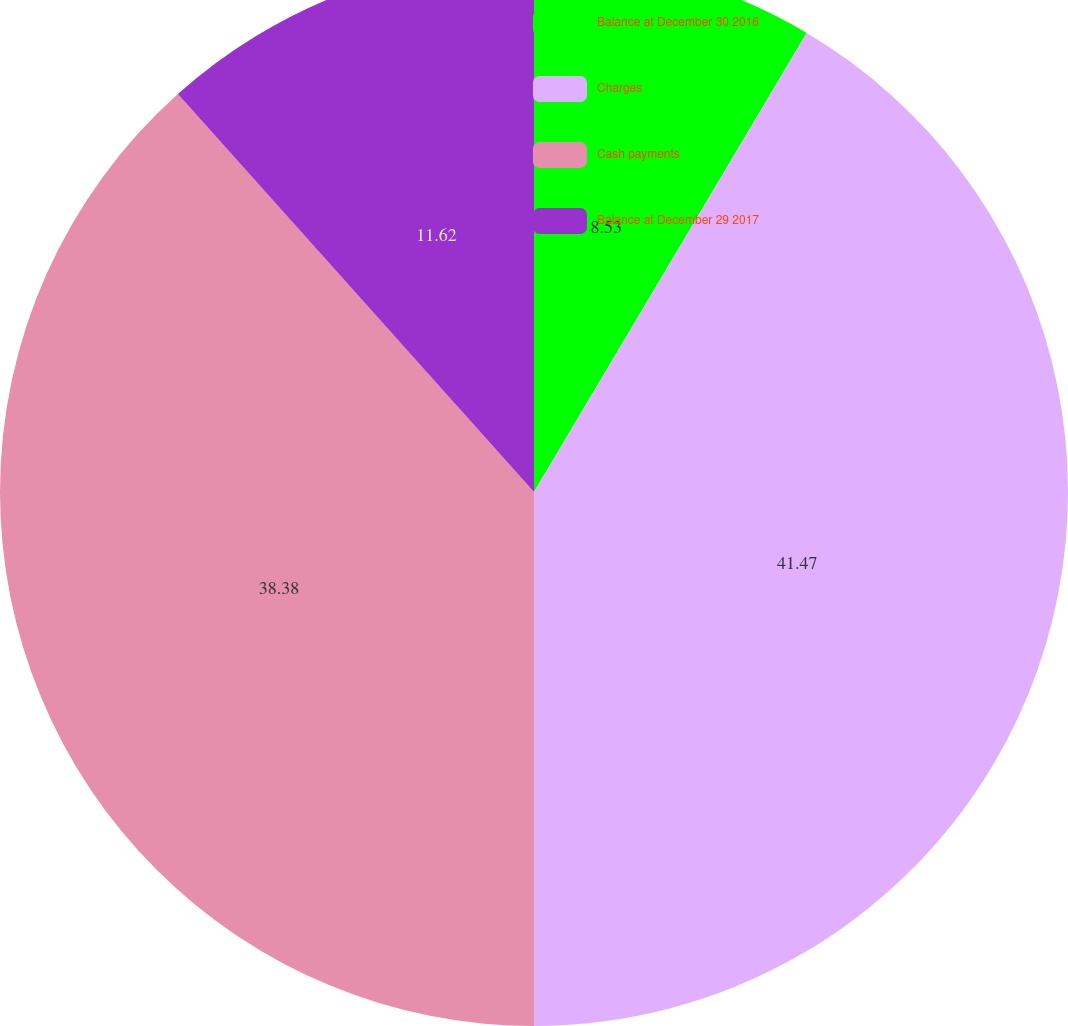<chart> <loc_0><loc_0><loc_500><loc_500><pie_chart><fcel>Balance at December 30 2016<fcel>Charges<fcel>Cash payments<fcel>Balance at December 29 2017<nl><fcel>8.53%<fcel>41.47%<fcel>38.38%<fcel>11.62%<nl></chart> 